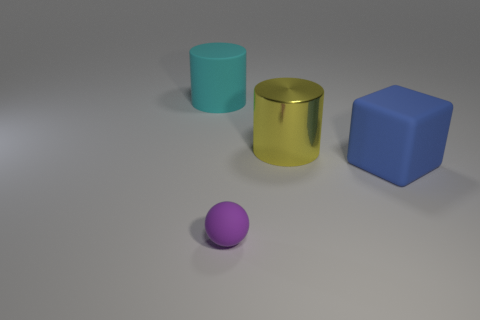Are there any other things that have the same shape as the tiny object?
Your response must be concise. No. What material is the large cyan cylinder?
Keep it short and to the point. Rubber. Are there any things right of the small object?
Provide a short and direct response. Yes. Is the shape of the purple thing the same as the big yellow metal thing?
Keep it short and to the point. No. What number of other objects are the same size as the block?
Ensure brevity in your answer.  2. What number of objects are cyan things behind the large blue matte object or blue matte cubes?
Your response must be concise. 2. The shiny thing is what color?
Your answer should be very brief. Yellow. There is a cylinder that is to the right of the tiny purple thing; what is it made of?
Keep it short and to the point. Metal. There is a tiny object; is it the same shape as the big object that is behind the large shiny cylinder?
Ensure brevity in your answer.  No. Are there more things than big red metal spheres?
Ensure brevity in your answer.  Yes. 